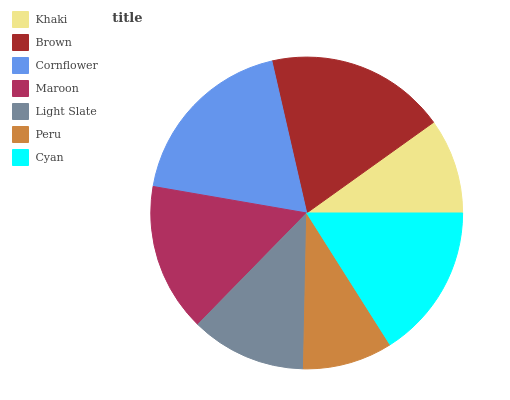Is Peru the minimum?
Answer yes or no. Yes. Is Brown the maximum?
Answer yes or no. Yes. Is Cornflower the minimum?
Answer yes or no. No. Is Cornflower the maximum?
Answer yes or no. No. Is Brown greater than Cornflower?
Answer yes or no. Yes. Is Cornflower less than Brown?
Answer yes or no. Yes. Is Cornflower greater than Brown?
Answer yes or no. No. Is Brown less than Cornflower?
Answer yes or no. No. Is Maroon the high median?
Answer yes or no. Yes. Is Maroon the low median?
Answer yes or no. Yes. Is Peru the high median?
Answer yes or no. No. Is Peru the low median?
Answer yes or no. No. 